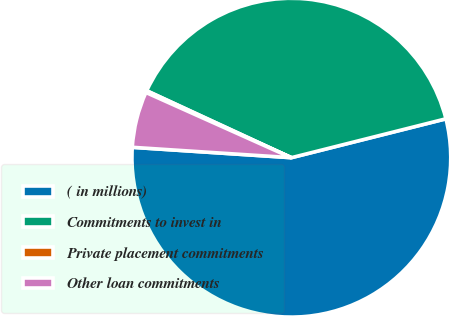Convert chart. <chart><loc_0><loc_0><loc_500><loc_500><pie_chart><fcel>( in millions)<fcel>Commitments to invest in<fcel>Private placement commitments<fcel>Other loan commitments<nl><fcel>54.96%<fcel>39.18%<fcel>0.19%<fcel>5.67%<nl></chart> 